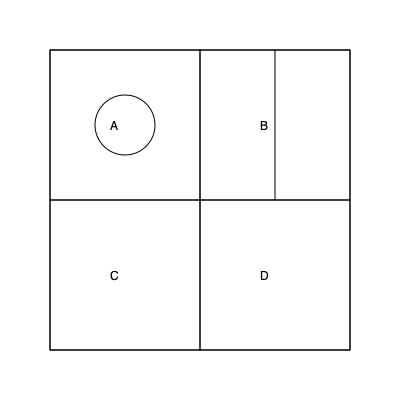Based on the floorplan of an Anglo-Saxon settlement shown above, which room is most likely to be the main hall, and why? To determine the main hall in this Anglo-Saxon settlement floorplan, we need to consider the following steps:

1. Analyze the layout: The floorplan shows four rooms (A, B, C, and D) arranged in a square formation.

2. Identify distinctive features:
   - Room A has a circular structure inside, possibly a hearth.
   - Room B is divided into two sections by a line.
   - Rooms C and D have no distinctive internal features.

3. Consider Anglo-Saxon architectural norms:
   - The main hall was typically the largest and most central room in a settlement.
   - It often contained a central hearth for warmth, cooking, and as a focal point for gatherings.
   - Other rooms were usually smaller and used for storage, sleeping, or specialized activities.

4. Apply this knowledge to the floorplan:
   - Room A is the only one with a circular structure, likely representing a central hearth.
   - Its position in the top-left corner makes it easily accessible.
   - The presence of a hearth suggests it was used for communal gatherings and activities.

5. Conclusion: Room A is most likely the main hall due to its distinctive feature (the hearth) and its suitability for communal activities, which were central to Anglo-Saxon life.
Answer: Room A, due to the presence of a central hearth. 